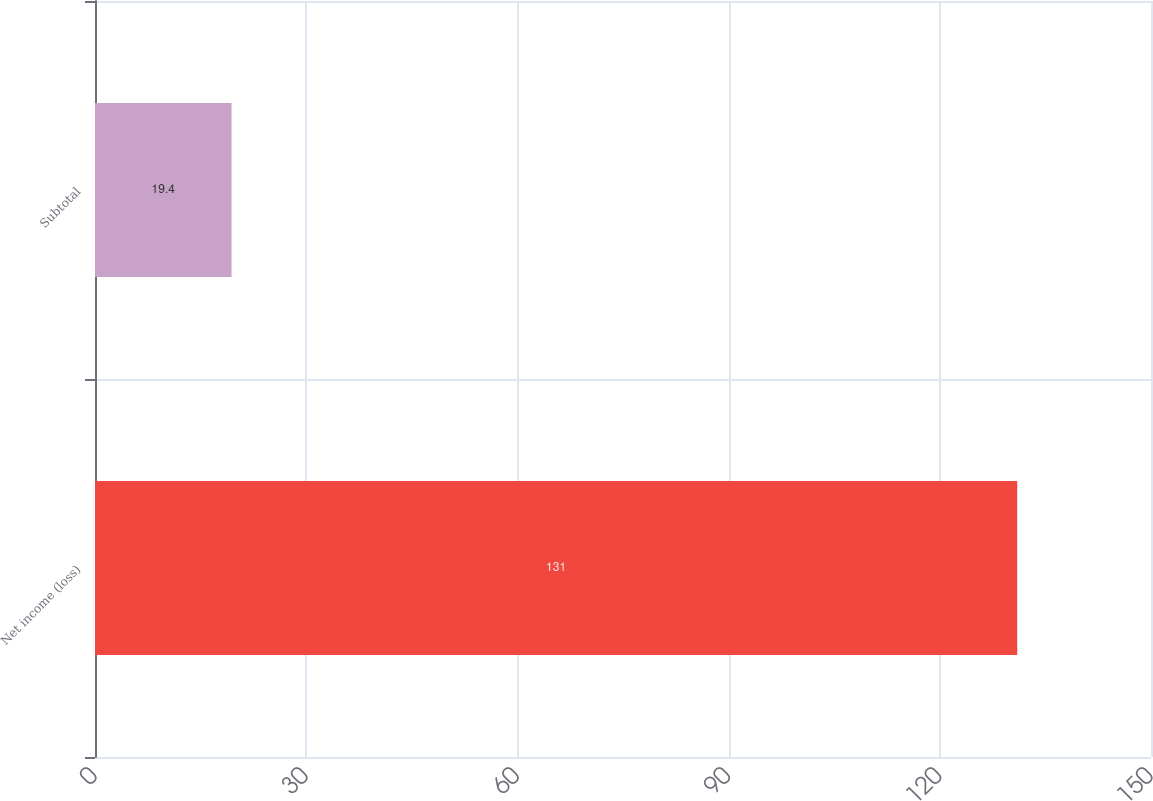<chart> <loc_0><loc_0><loc_500><loc_500><bar_chart><fcel>Net income (loss)<fcel>Subtotal<nl><fcel>131<fcel>19.4<nl></chart> 